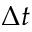Convert formula to latex. <formula><loc_0><loc_0><loc_500><loc_500>\Delta t</formula> 